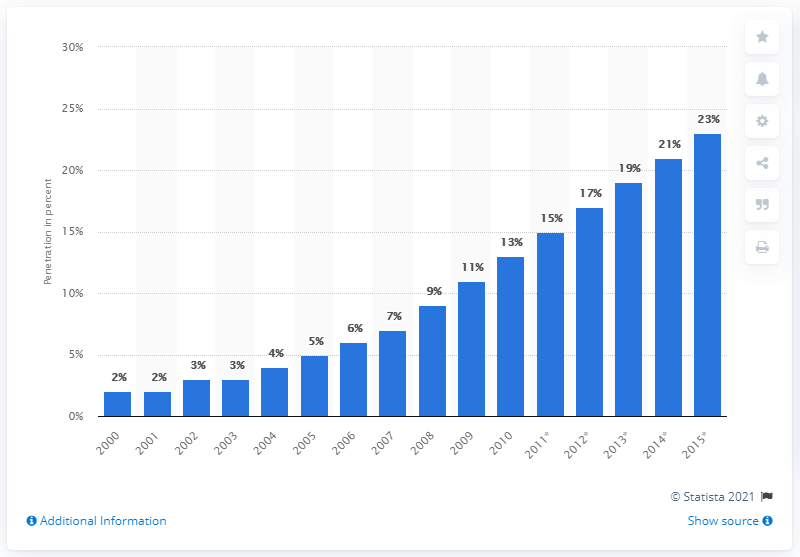Outline some significant characteristics in this image. In 2006, the penetration of consumer PCs per capita in Eastern Europe was approximately 6%. In 2015, the projected PC penetration per capita was estimated to be 23%. 